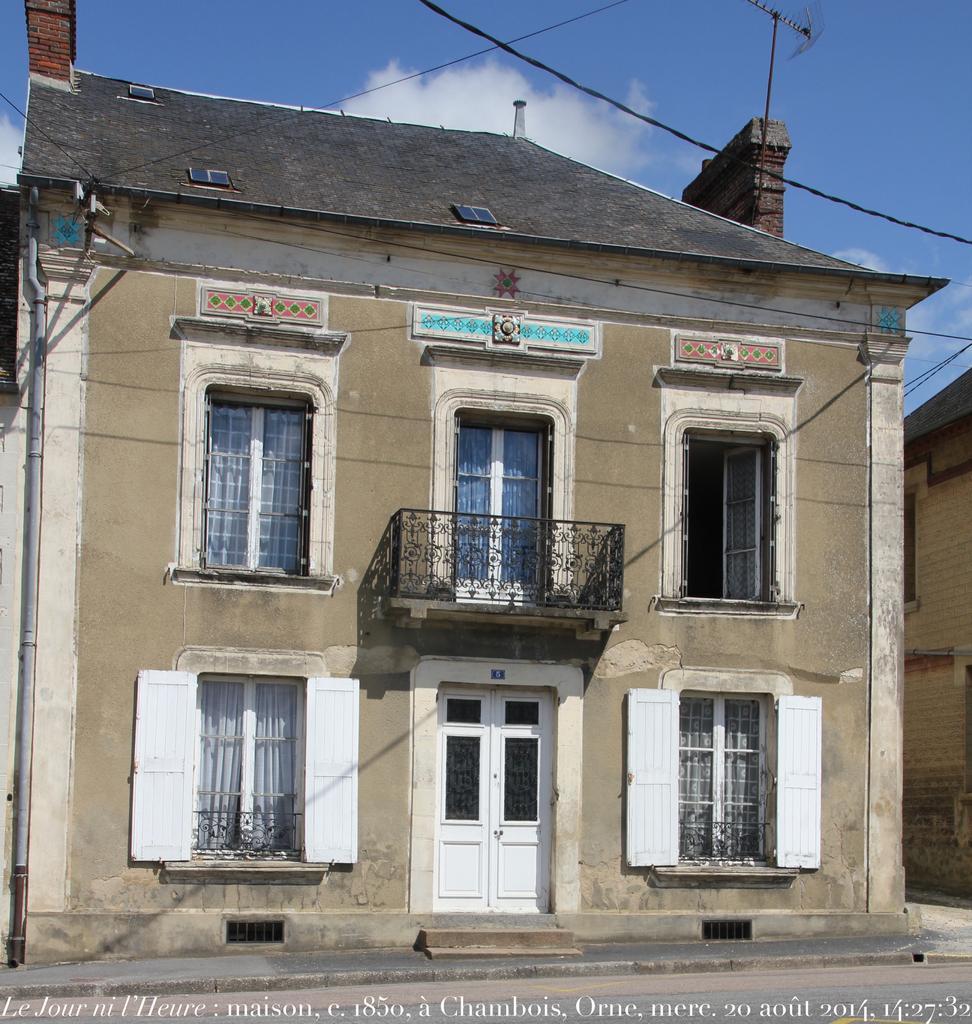Can you describe this image briefly? In this image we can see two houses, some curtains, some text on the bottom of the image, three wires, one pipe attached to the house wall, one antenna on the top of the house, one object attached to the house wall and at the top there is the cloudy sky. 